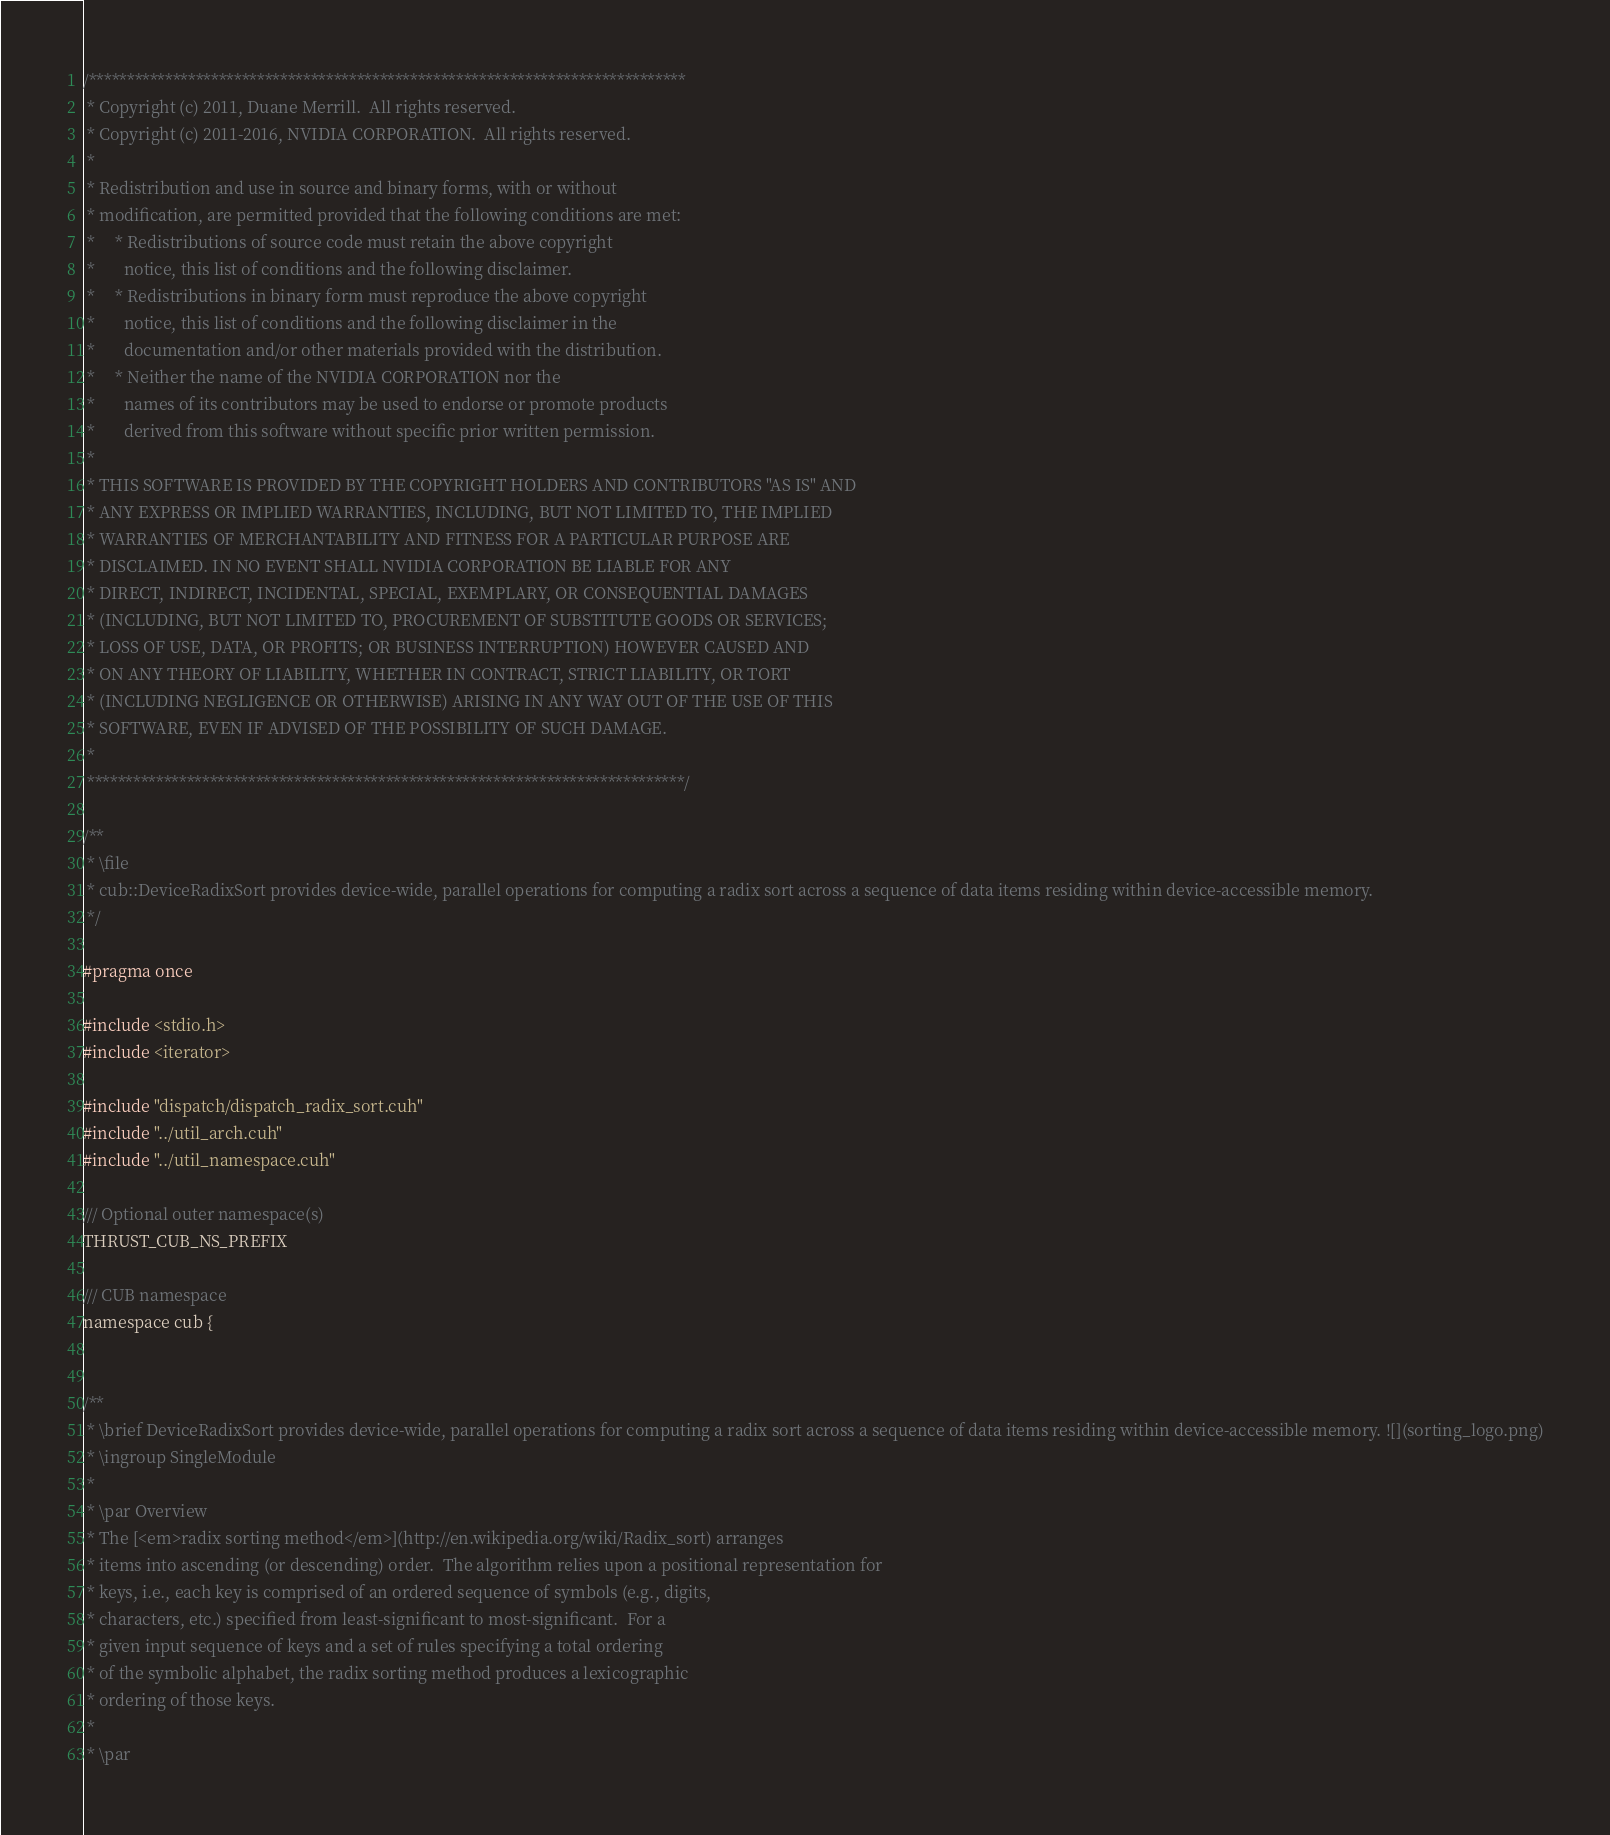<code> <loc_0><loc_0><loc_500><loc_500><_Cuda_>
/******************************************************************************
 * Copyright (c) 2011, Duane Merrill.  All rights reserved.
 * Copyright (c) 2011-2016, NVIDIA CORPORATION.  All rights reserved.
 *
 * Redistribution and use in source and binary forms, with or without
 * modification, are permitted provided that the following conditions are met:
 *     * Redistributions of source code must retain the above copyright
 *       notice, this list of conditions and the following disclaimer.
 *     * Redistributions in binary form must reproduce the above copyright
 *       notice, this list of conditions and the following disclaimer in the
 *       documentation and/or other materials provided with the distribution.
 *     * Neither the name of the NVIDIA CORPORATION nor the
 *       names of its contributors may be used to endorse or promote products
 *       derived from this software without specific prior written permission.
 *
 * THIS SOFTWARE IS PROVIDED BY THE COPYRIGHT HOLDERS AND CONTRIBUTORS "AS IS" AND
 * ANY EXPRESS OR IMPLIED WARRANTIES, INCLUDING, BUT NOT LIMITED TO, THE IMPLIED
 * WARRANTIES OF MERCHANTABILITY AND FITNESS FOR A PARTICULAR PURPOSE ARE
 * DISCLAIMED. IN NO EVENT SHALL NVIDIA CORPORATION BE LIABLE FOR ANY
 * DIRECT, INDIRECT, INCIDENTAL, SPECIAL, EXEMPLARY, OR CONSEQUENTIAL DAMAGES
 * (INCLUDING, BUT NOT LIMITED TO, PROCUREMENT OF SUBSTITUTE GOODS OR SERVICES;
 * LOSS OF USE, DATA, OR PROFITS; OR BUSINESS INTERRUPTION) HOWEVER CAUSED AND
 * ON ANY THEORY OF LIABILITY, WHETHER IN CONTRACT, STRICT LIABILITY, OR TORT
 * (INCLUDING NEGLIGENCE OR OTHERWISE) ARISING IN ANY WAY OUT OF THE USE OF THIS
 * SOFTWARE, EVEN IF ADVISED OF THE POSSIBILITY OF SUCH DAMAGE.
 *
 ******************************************************************************/

/**
 * \file
 * cub::DeviceRadixSort provides device-wide, parallel operations for computing a radix sort across a sequence of data items residing within device-accessible memory.
 */

#pragma once

#include <stdio.h>
#include <iterator>

#include "dispatch/dispatch_radix_sort.cuh"
#include "../util_arch.cuh"
#include "../util_namespace.cuh"

/// Optional outer namespace(s)
THRUST_CUB_NS_PREFIX

/// CUB namespace
namespace cub {


/**
 * \brief DeviceRadixSort provides device-wide, parallel operations for computing a radix sort across a sequence of data items residing within device-accessible memory. ![](sorting_logo.png)
 * \ingroup SingleModule
 *
 * \par Overview
 * The [<em>radix sorting method</em>](http://en.wikipedia.org/wiki/Radix_sort) arranges
 * items into ascending (or descending) order.  The algorithm relies upon a positional representation for
 * keys, i.e., each key is comprised of an ordered sequence of symbols (e.g., digits,
 * characters, etc.) specified from least-significant to most-significant.  For a
 * given input sequence of keys and a set of rules specifying a total ordering
 * of the symbolic alphabet, the radix sorting method produces a lexicographic
 * ordering of those keys.
 *
 * \par</code> 